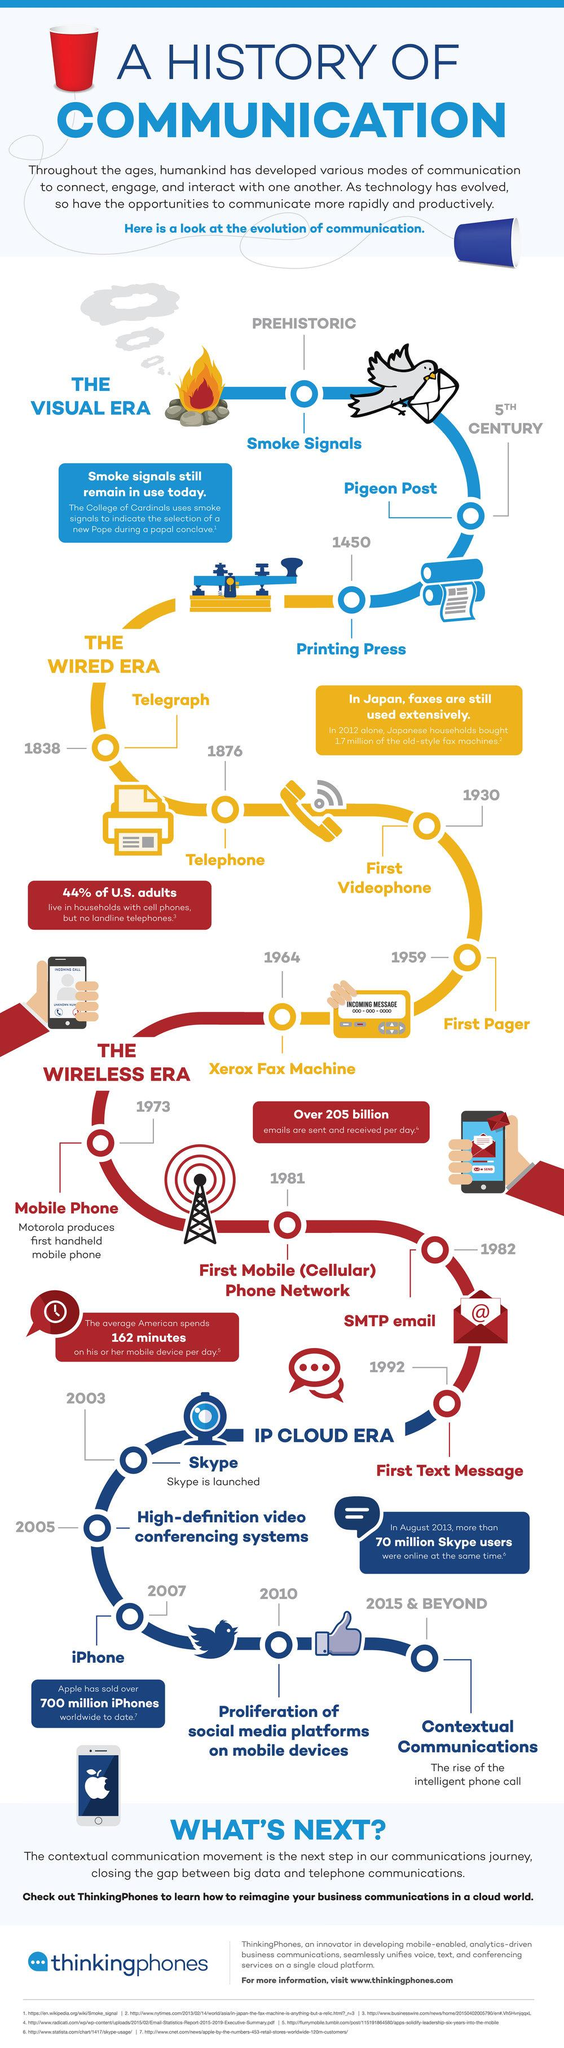Draw attention to some important aspects in this diagram. The first text message was sent in 1992. The first videophone was invented in 1930. The Xerox fax machine was invented in 1964. The telephone was invented in the year 1876. 